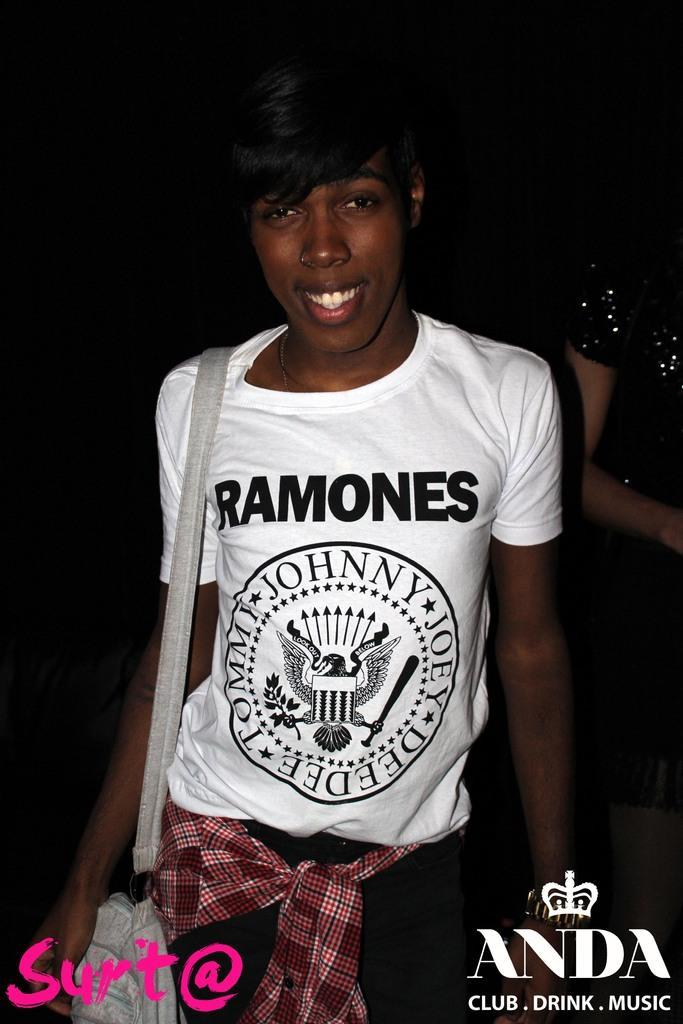Can you describe this image briefly? In this image, we can see a person on the dark background wearing clothes and bag. 